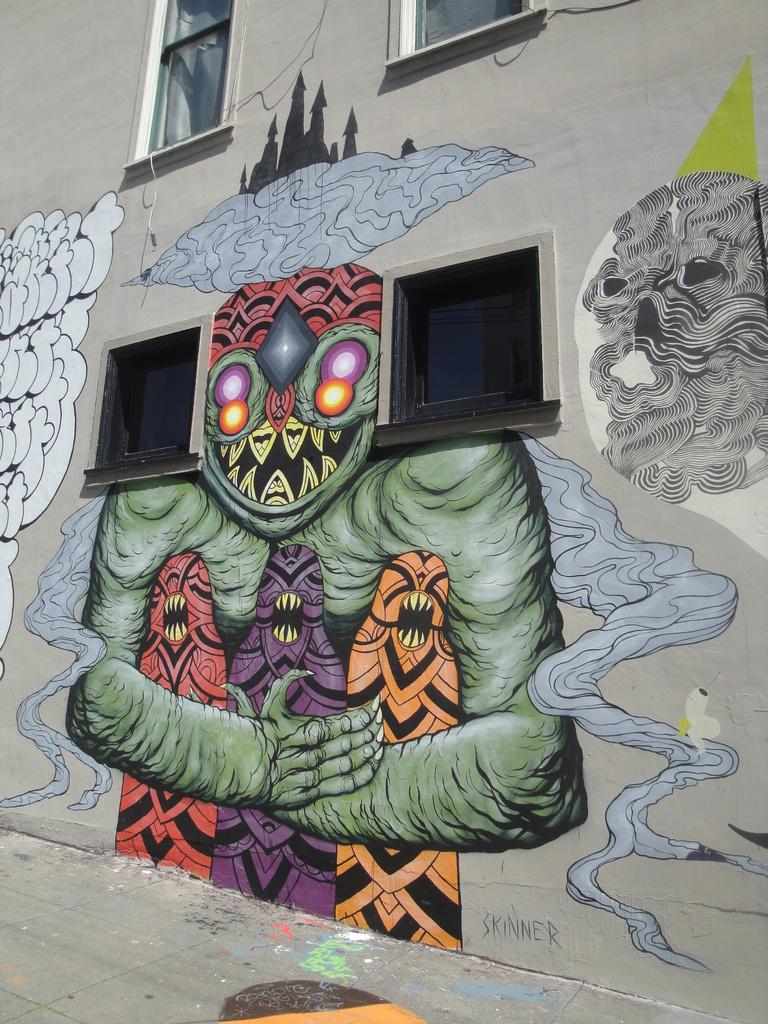What is depicted on the wall in the image? There is a painting of monsters on a wall in the image. What type of structure is the wall part of? The wall is part of a building. What type of architectural feature can be seen in the image? There are glass windows in the image. What type of memory is stored on the tray in the image? There is no tray present in the image, and therefore no memory can be stored on it. 